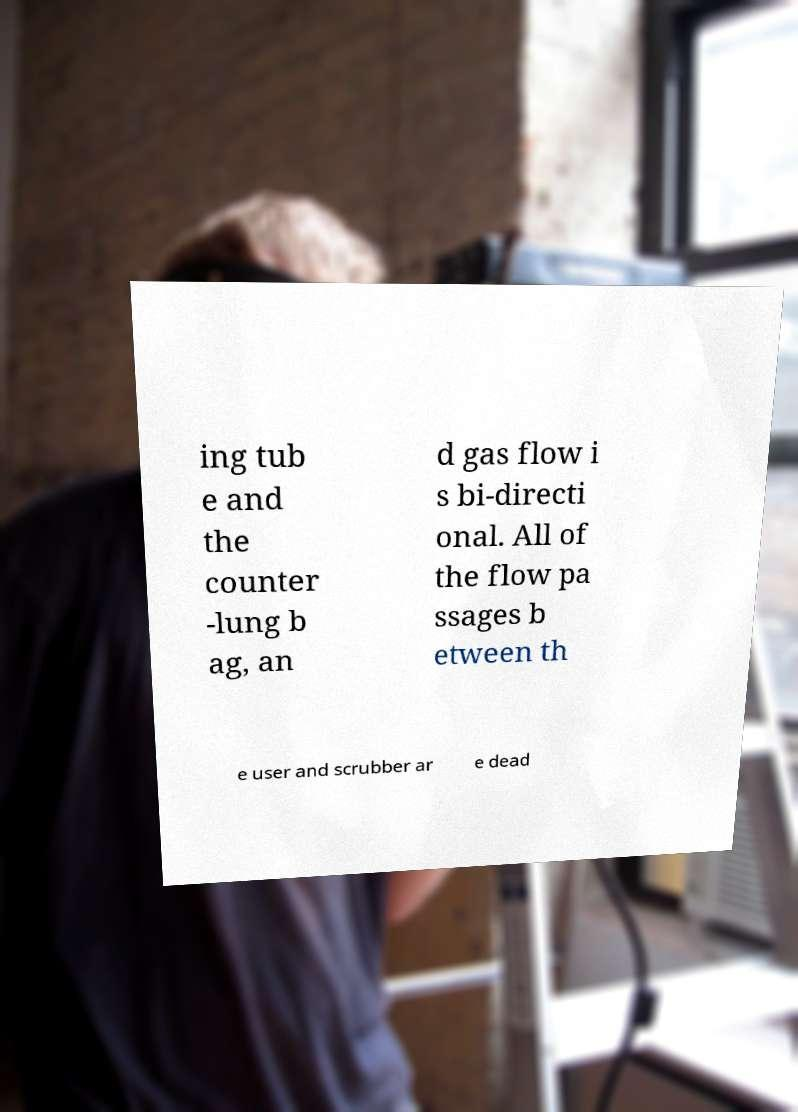Can you read and provide the text displayed in the image?This photo seems to have some interesting text. Can you extract and type it out for me? ing tub e and the counter -lung b ag, an d gas flow i s bi-directi onal. All of the flow pa ssages b etween th e user and scrubber ar e dead 